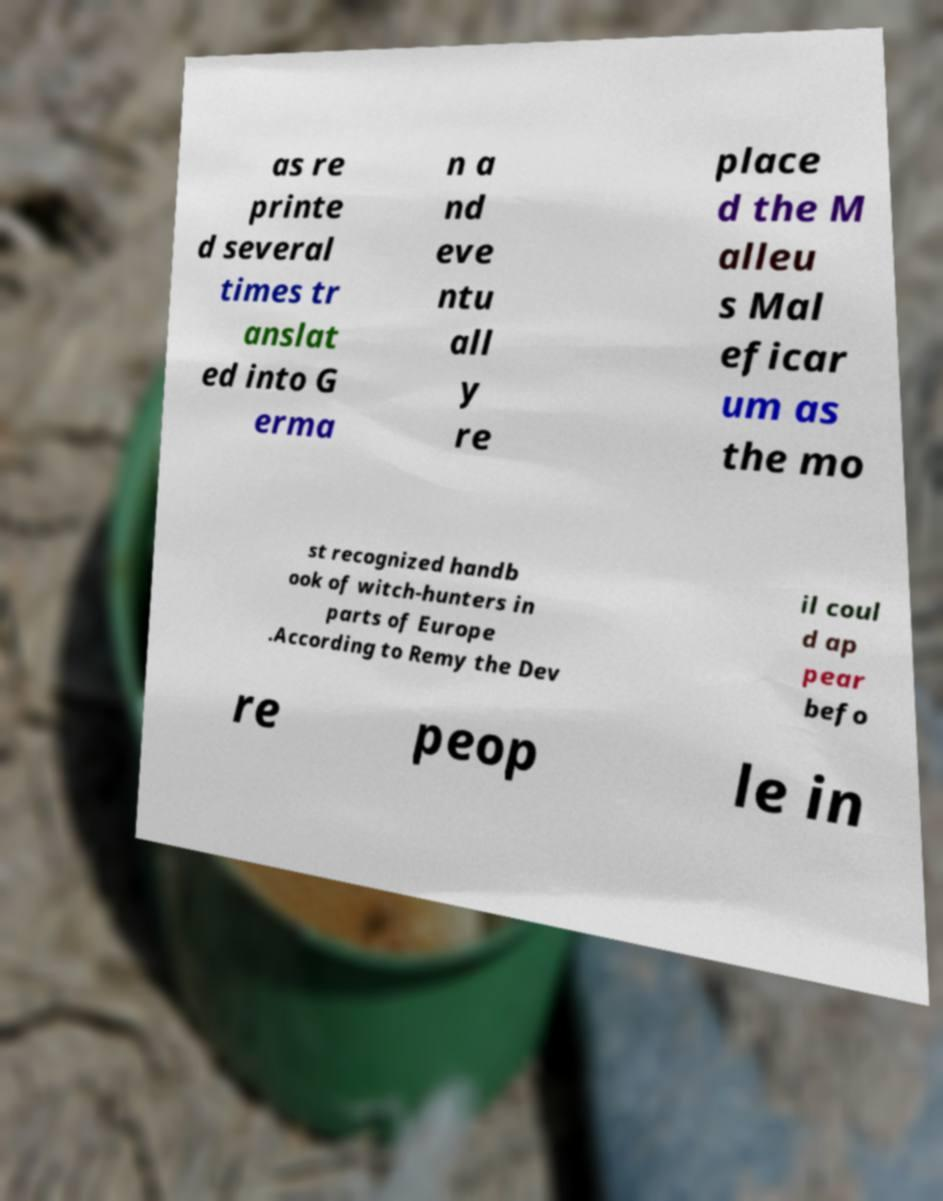Please identify and transcribe the text found in this image. as re printe d several times tr anslat ed into G erma n a nd eve ntu all y re place d the M alleu s Mal eficar um as the mo st recognized handb ook of witch-hunters in parts of Europe .According to Remy the Dev il coul d ap pear befo re peop le in 